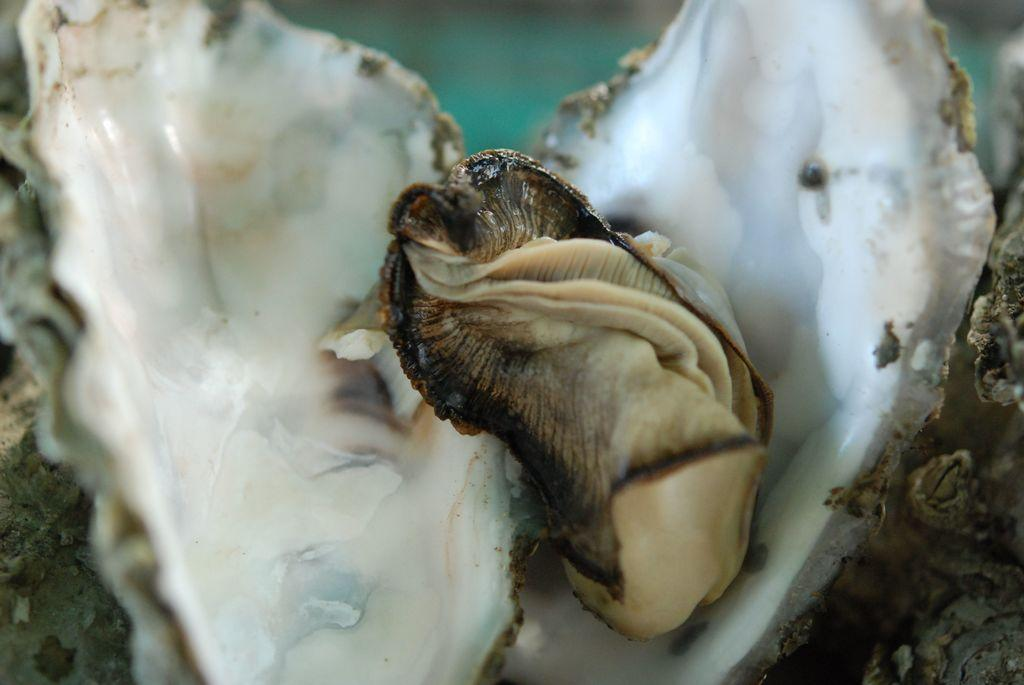What type of animal is depicted in the image? There is a seashell animal in the image. How many tents can be seen in the image? There are no tents present in the image; it features a seashell animal. What color are the eyes of the animal in the image? The image does not show the animal's eyes, as it is a seashell animal. 